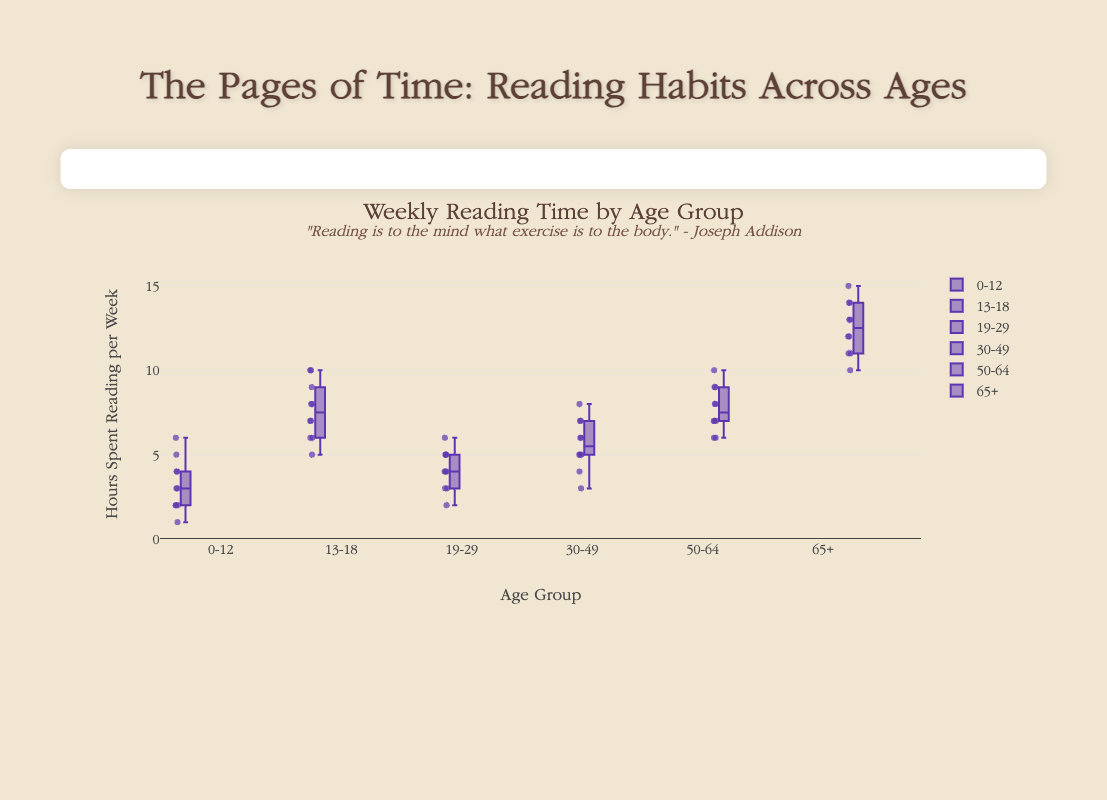What is the median reading time for the age group 0-12? In the figure, locate the 0-12 age group's box plot and identify the line inside the box, which represents the median.
Answer: 3 hours Which age group has the highest median reading time? Compare the medians of all age groups by examining the central lines in the box plots. The 65+ age group has the highest median reading time.
Answer: 65+ How does the reading time in the 13-18 age group generally compare to the 19-29 age group? Compare the overall spread and median of the box plots for both age groups. The 13-18 group generally spends more time reading and has a higher median value.
Answer: 13-18 reads more What is the difference in the upper whisker values between the 50-64 and 65+ age groups? Locate the upper whiskers of both box plots and subtract the 50-64 age group's upper whisker value from the 65+ age group's upper whisker value. The upper whisker in the 50-64 age group is 10, and in the 65+ group, it is 15. Therefore, 15 - 10 = 5.
Answer: 5 hours Which age group has the smallest interquartile range (IQR), and what is it? Measure the distance between the top and bottom of the boxes (third quartile minus first quartile) for all age groups. The 19-29 age group has the smallest IQR.
Answer: 2 hours In which age group are there more outliers visible? Look for outliers, which appear as points outside the whiskers of the box plots. The 30-49 age group has more visible outliers.
Answer: 30-49 What is the range of reading times for the 65+ age group? Identify the minimum and maximum values (whiskers) and subtract the smallest value from the largest. The minimum is 10, and the maximum is 15. Therefore, 15 - 10 = 5.
Answer: 5 hours Which age group has the widest range of reading times? Compare the lengths of the whiskers for all the age groups. The 65+ age group has the widest range.
Answer: 65+ What is the average reading time for the age group 19-29? Sum up all the reading times for this group (4+5+3+2+4+5+3+6+4+5) and then divide by the number of data points (10). The total is 41, so the average is 41/10 = 4.1.
Answer: 4.1 hours Which age group displays the most consistent reading habits and why? Determine the age group with the smallest interquartile range, indicating less variability. The 19-29 age group has the smallest IQR, suggesting more consistent reading habits.
Answer: 19-29 